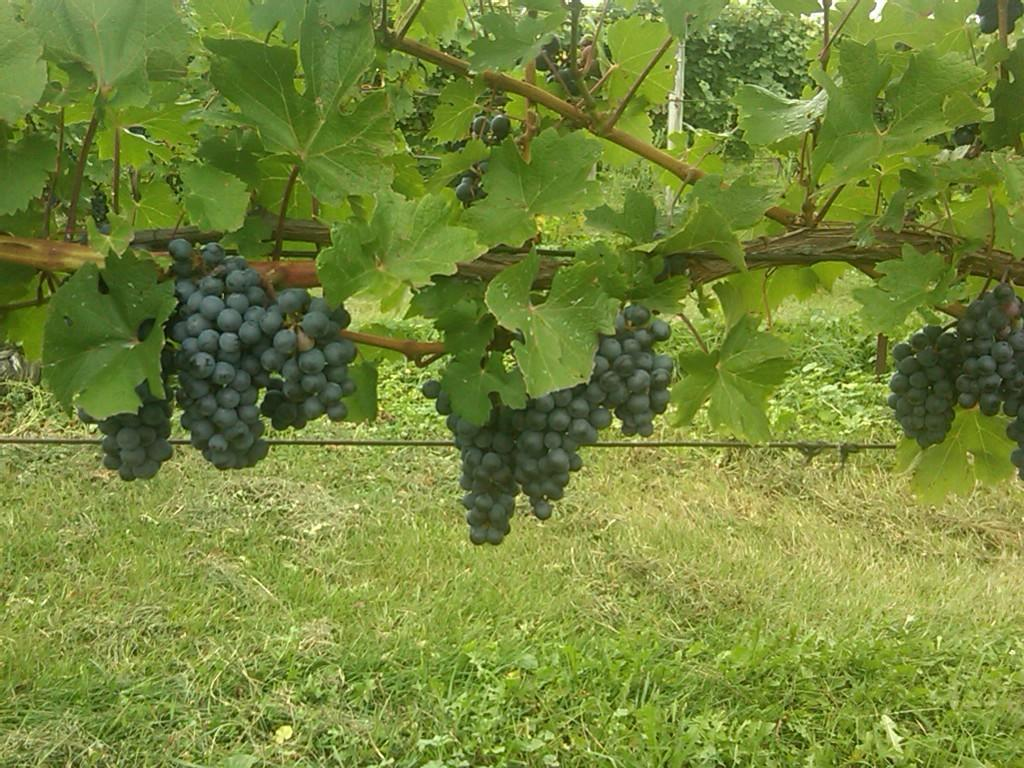What type of plant is in the image? There is a grape plant in the image. What color are the grapes on the plant? The grape plant has black grapes. What type of vegetation is at the bottom of the image? There is grass at the bottom of the image. How many geese are walking on the grape plant in the image? There are no geese present in the image. What type of lunch is being served on the grape plant in the image? There is no lunch being served on the grape plant in the image. --- Facts: 1. There is a person in the image. 2. The person is wearing a hat. 3. The person is holding a book. 4. The person is sitting on a chair. 5. There is a table in the image. Absurd Topics: unicorn, basketball Conversation: Who or what is in the image? There is a person in the image. What is the person wearing? The person is wearing a hat. What is the person holding? The person is holding a book. What is the person doing? The person is sitting on a chair. What else can be seen in the image? There is a table in the image. Reasoning: Let's think step by step in order to produce the conversation. We start by identifying the main subject in the image, which is the person. Then, we describe specific details about the person, such as the hat and the book they are holding. Next, we observe the actions of the person, noting that they are sitting on a chair. Finally, we describe any other objects or elements in the image, such as the table. Absurd Question/Answer: Can you see a unicorn playing basketball in the image? No, there is no unicorn playing basketball in the image. 